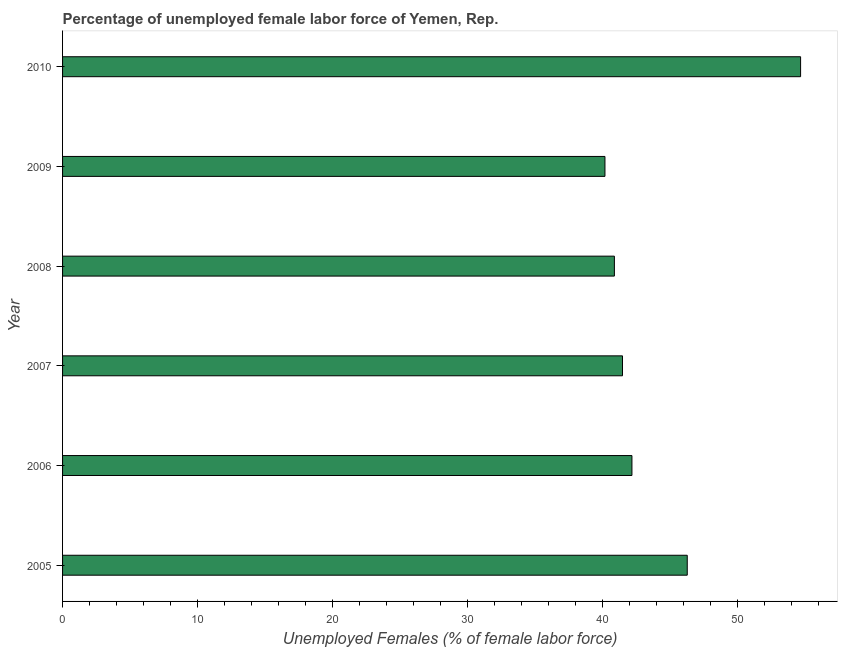Does the graph contain any zero values?
Provide a succinct answer. No. What is the title of the graph?
Provide a succinct answer. Percentage of unemployed female labor force of Yemen, Rep. What is the label or title of the X-axis?
Give a very brief answer. Unemployed Females (% of female labor force). What is the total unemployed female labour force in 2008?
Your response must be concise. 40.9. Across all years, what is the maximum total unemployed female labour force?
Offer a terse response. 54.7. Across all years, what is the minimum total unemployed female labour force?
Give a very brief answer. 40.2. What is the sum of the total unemployed female labour force?
Make the answer very short. 265.8. What is the average total unemployed female labour force per year?
Your answer should be very brief. 44.3. What is the median total unemployed female labour force?
Your response must be concise. 41.85. What is the ratio of the total unemployed female labour force in 2007 to that in 2009?
Provide a short and direct response. 1.03. Is the total unemployed female labour force in 2006 less than that in 2008?
Offer a terse response. No. Is the difference between the total unemployed female labour force in 2005 and 2007 greater than the difference between any two years?
Make the answer very short. No. What is the difference between the highest and the second highest total unemployed female labour force?
Provide a short and direct response. 8.4. Is the sum of the total unemployed female labour force in 2007 and 2009 greater than the maximum total unemployed female labour force across all years?
Keep it short and to the point. Yes. What is the Unemployed Females (% of female labor force) in 2005?
Ensure brevity in your answer.  46.3. What is the Unemployed Females (% of female labor force) of 2006?
Ensure brevity in your answer.  42.2. What is the Unemployed Females (% of female labor force) of 2007?
Ensure brevity in your answer.  41.5. What is the Unemployed Females (% of female labor force) in 2008?
Provide a short and direct response. 40.9. What is the Unemployed Females (% of female labor force) in 2009?
Offer a terse response. 40.2. What is the Unemployed Females (% of female labor force) of 2010?
Keep it short and to the point. 54.7. What is the difference between the Unemployed Females (% of female labor force) in 2005 and 2007?
Your answer should be very brief. 4.8. What is the difference between the Unemployed Females (% of female labor force) in 2005 and 2009?
Provide a short and direct response. 6.1. What is the difference between the Unemployed Females (% of female labor force) in 2005 and 2010?
Make the answer very short. -8.4. What is the difference between the Unemployed Females (% of female labor force) in 2006 and 2007?
Provide a succinct answer. 0.7. What is the difference between the Unemployed Females (% of female labor force) in 2006 and 2010?
Your answer should be very brief. -12.5. What is the difference between the Unemployed Females (% of female labor force) in 2008 and 2009?
Your answer should be very brief. 0.7. What is the difference between the Unemployed Females (% of female labor force) in 2008 and 2010?
Ensure brevity in your answer.  -13.8. What is the difference between the Unemployed Females (% of female labor force) in 2009 and 2010?
Make the answer very short. -14.5. What is the ratio of the Unemployed Females (% of female labor force) in 2005 to that in 2006?
Your answer should be very brief. 1.1. What is the ratio of the Unemployed Females (% of female labor force) in 2005 to that in 2007?
Provide a succinct answer. 1.12. What is the ratio of the Unemployed Females (% of female labor force) in 2005 to that in 2008?
Provide a succinct answer. 1.13. What is the ratio of the Unemployed Females (% of female labor force) in 2005 to that in 2009?
Ensure brevity in your answer.  1.15. What is the ratio of the Unemployed Females (% of female labor force) in 2005 to that in 2010?
Your answer should be compact. 0.85. What is the ratio of the Unemployed Females (% of female labor force) in 2006 to that in 2008?
Your answer should be compact. 1.03. What is the ratio of the Unemployed Females (% of female labor force) in 2006 to that in 2009?
Provide a short and direct response. 1.05. What is the ratio of the Unemployed Females (% of female labor force) in 2006 to that in 2010?
Ensure brevity in your answer.  0.77. What is the ratio of the Unemployed Females (% of female labor force) in 2007 to that in 2009?
Provide a succinct answer. 1.03. What is the ratio of the Unemployed Females (% of female labor force) in 2007 to that in 2010?
Your answer should be compact. 0.76. What is the ratio of the Unemployed Females (% of female labor force) in 2008 to that in 2009?
Give a very brief answer. 1.02. What is the ratio of the Unemployed Females (% of female labor force) in 2008 to that in 2010?
Provide a succinct answer. 0.75. What is the ratio of the Unemployed Females (% of female labor force) in 2009 to that in 2010?
Give a very brief answer. 0.73. 